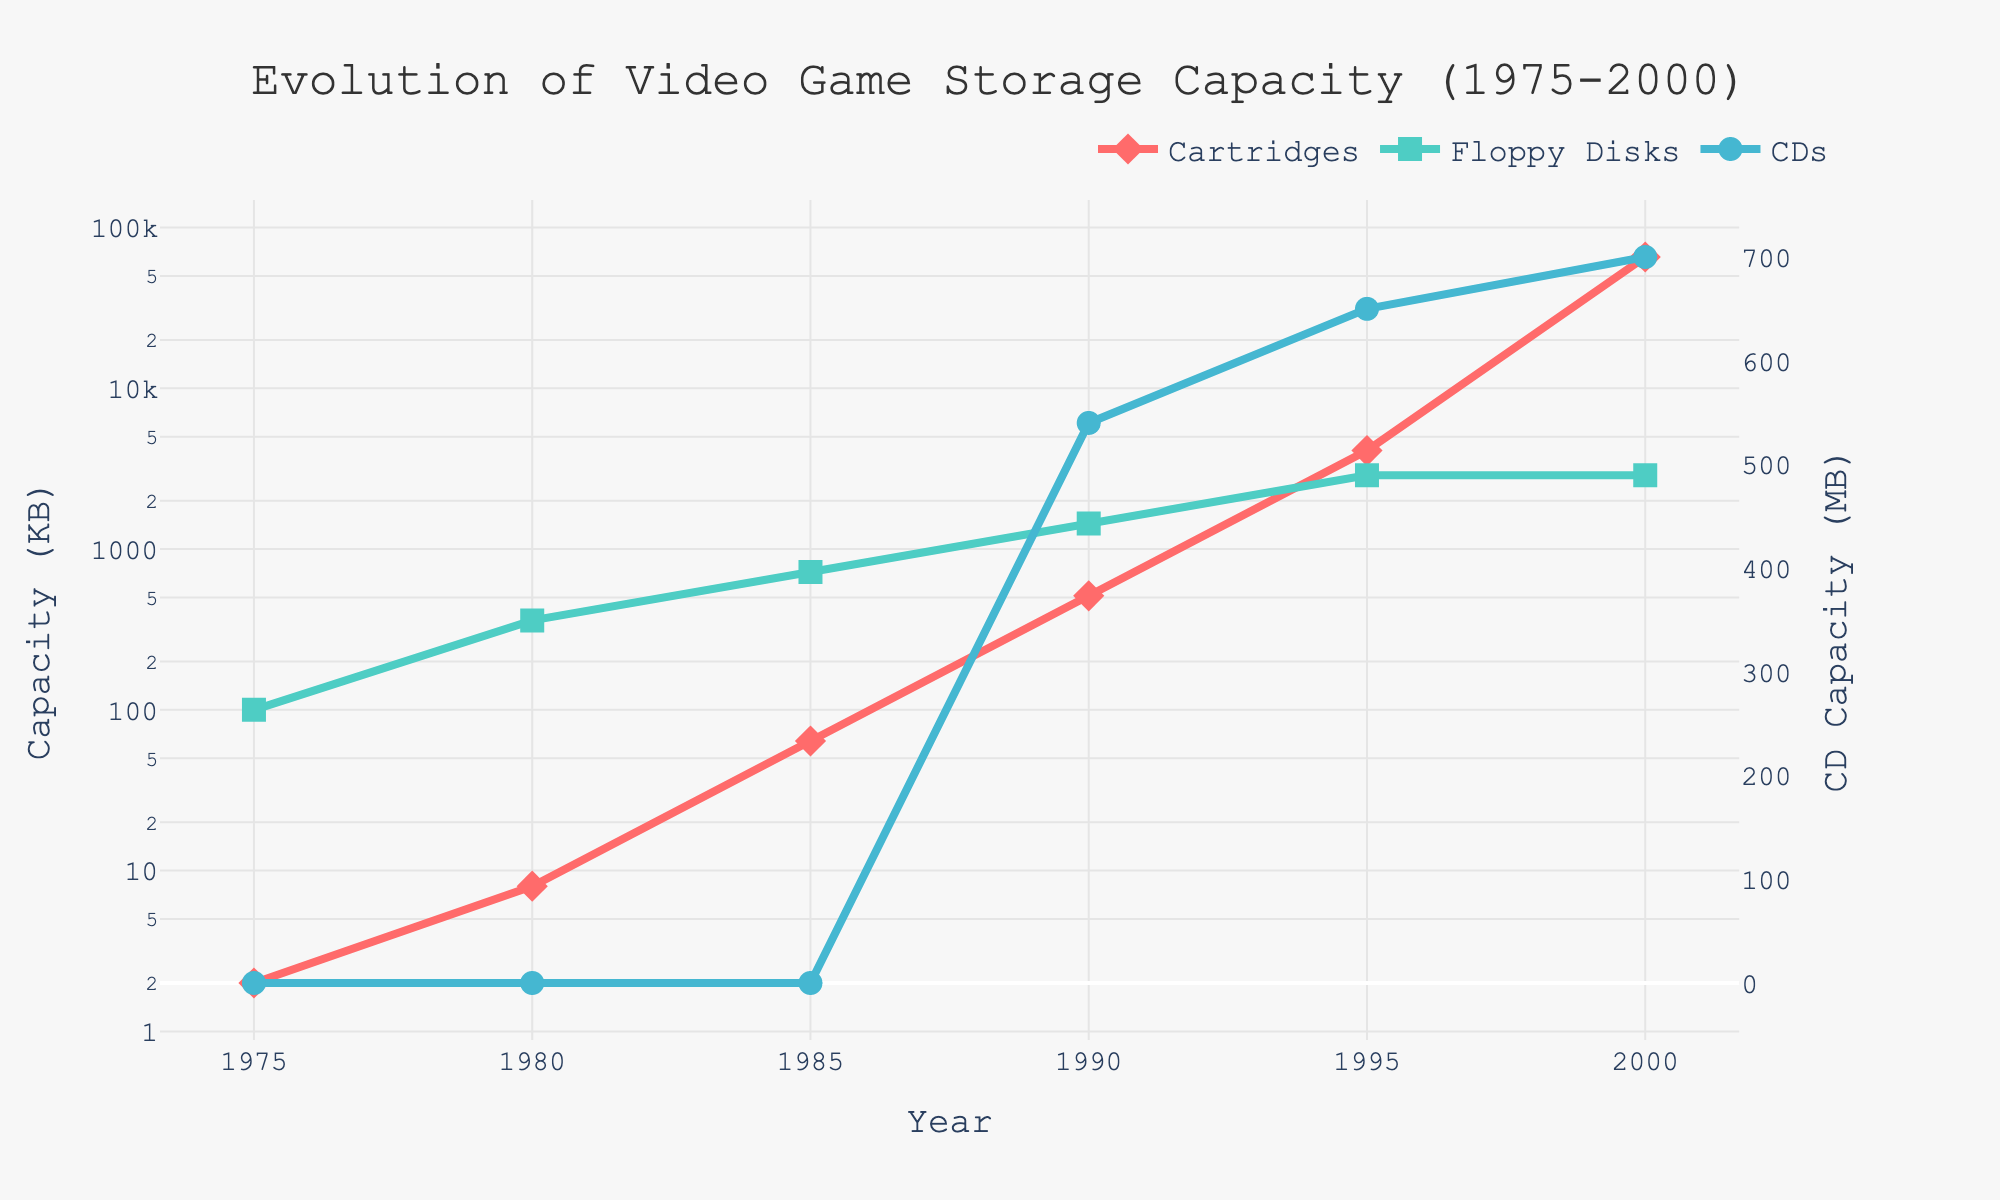What's the storage capacity of cartridges in 1980? From the plot, look at the value of the 'Cartridges' line at the year 1980.
Answer: 8 KB How much did the storage capacity of floppy disks increase from 1975 to 1995? Check the values of the 'Floppy Disks' line at the years 1975 and 1995 and calculate the difference. In 1975, it was 100 KB and in 1995, it was 2880 KB. So, 2880 - 100.
Answer: 2780 KB Which storage medium reached its maximum capacity first based on the figure, floppy disks or cartridges? Compare the peaks of the 'Floppy Disks' and 'Cartridges' lines over the timeline. Floppy disks reach their peak of 2880 KB in 1995, while cartridges reach 65536 KB in 2000.
Answer: Floppy disks By how many KB does the storage capacity of cartridges exceed that of floppy disks in the year 2000? Find the value for cartridges and floppy disks in the year 2000 from the plot. Cartridges have 65536 KB and floppy disks have 2880 KB. Subtract 2880 from 65536.
Answer: 62656 KB How much more storage capacity did CDs have compared to floppy disks in 1990? Check the values of both 'CDs' and 'Floppy Disks' lines at the year 1990. CDs have 540 MB and floppy disks have 1440 KB. Convert KB to MB (1440 KB = 1.44 MB) and subtract 1.44 from 540.
Answer: 538.56 MB In which year did cartridges surpass a storage capacity of 1 MB? Find the corresponding year when the 'Cartridges' line surpasses the 1024 KB (1 MB) mark. This occurs between 1990 and 1995.
Answer: 1995 At what year is the rate of increase in storage capacity for cartridges the highest? Observe the 'Cartridges' line and identify the steepest slope. The line shows a sharp increase between 1995 and 2000.
Answer: Between 1995 and 2000 Do CDs' storage capacities appear on the plot before 1990? Check the plot for any values along the 'CDs' line before the year 1990. There are no data points for CDs before 1990.
Answer: No Which media type was growing at a more consistent rate between 1975 and 2000, floppy disks or cartridges? Compare the trends of the 'Floppy Disks' and 'Cartridges' lines. Floppy disks show a steady rise from 1975 to 1995 and then plateau, while cartridges show slower growth initially and a sharp rise after 1995.
Answer: Floppy disks How many times did the storage capacity of cartridges increase from 1985 to 2000? Calculate the increment factor for 'Cartridges' line from the values in 1985 (64 KB) to 2000 (65536 KB). Use the formula: 65536 / 64.
Answer: 1024 times 